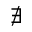Convert formula to latex. <formula><loc_0><loc_0><loc_500><loc_500>\nexists</formula> 